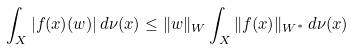Convert formula to latex. <formula><loc_0><loc_0><loc_500><loc_500>\int _ { X } | f ( x ) ( w ) | \, d \nu ( x ) \leq \| w \| _ { W } \int _ { X } \| f ( x ) \| _ { W ^ { * } } \, d \nu ( x )</formula> 